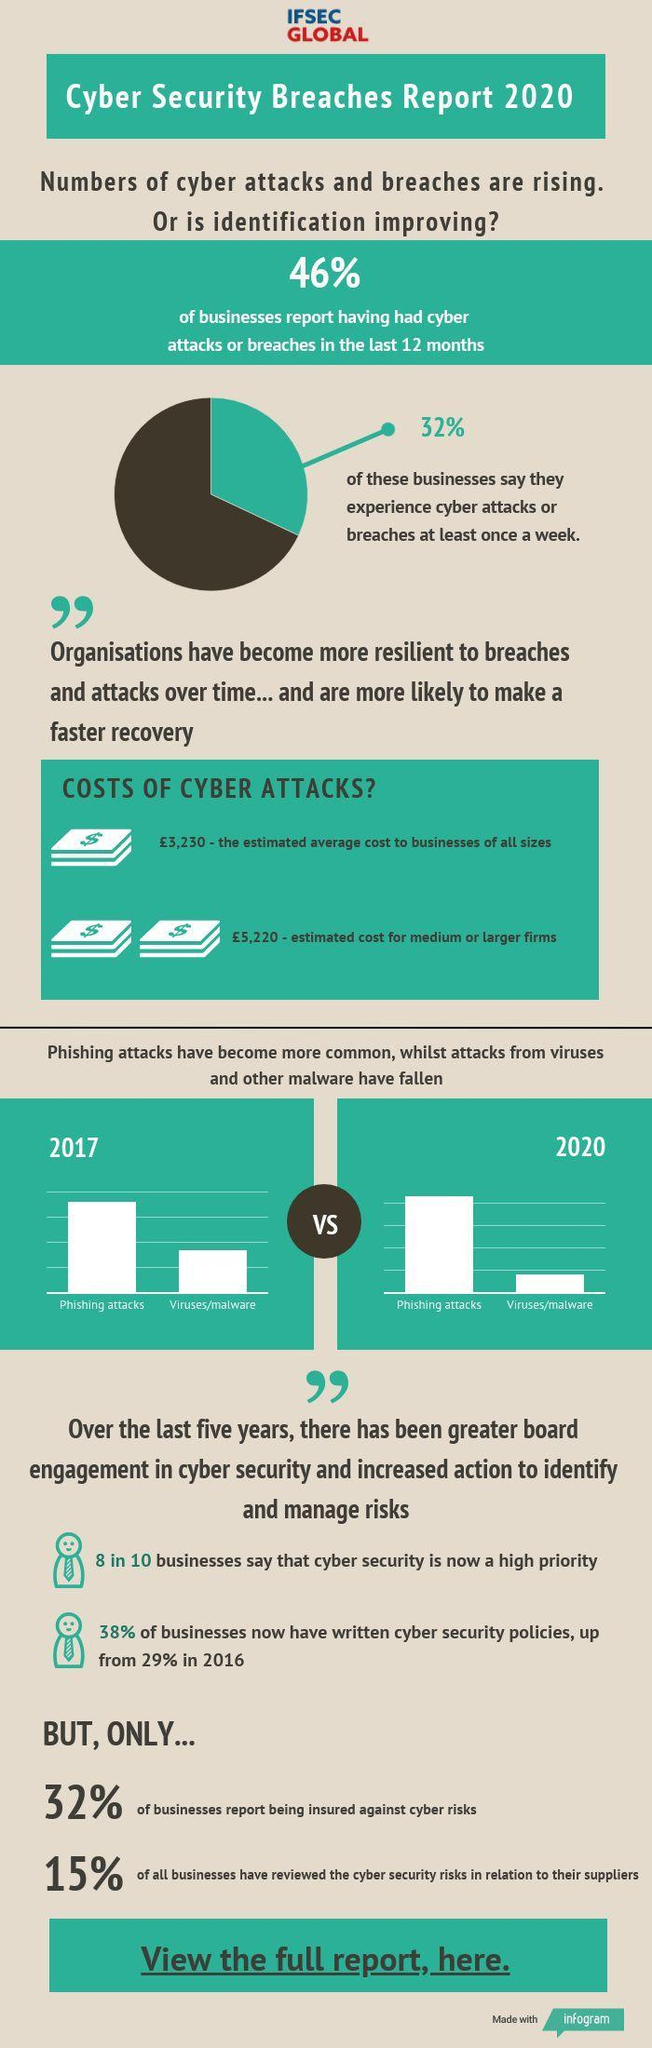What percentage of businesses report not being insured against cyber risks as per the Cyber Security Breaches Report 2020?
Answer the question with a short phrase. 68% What percentage of businesses say that they didn't experience any cyber attacks or breaches once in a week as per the Cyber Security Breaches Report 2020? 68% What percentage of all businesses have not reviewed the cyber security risks in relation to their suppliers as per the Cyber Security Breaches Report 2020? 85% 